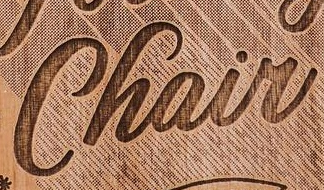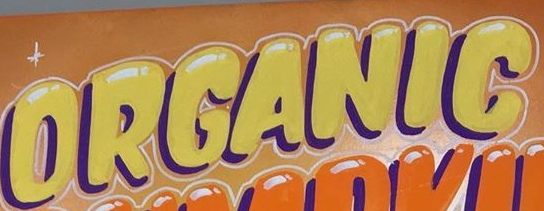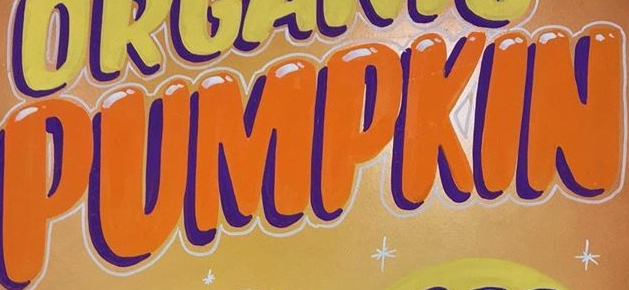What text is displayed in these images sequentially, separated by a semicolon? Chair; ORGANIG; PUMPKIN 